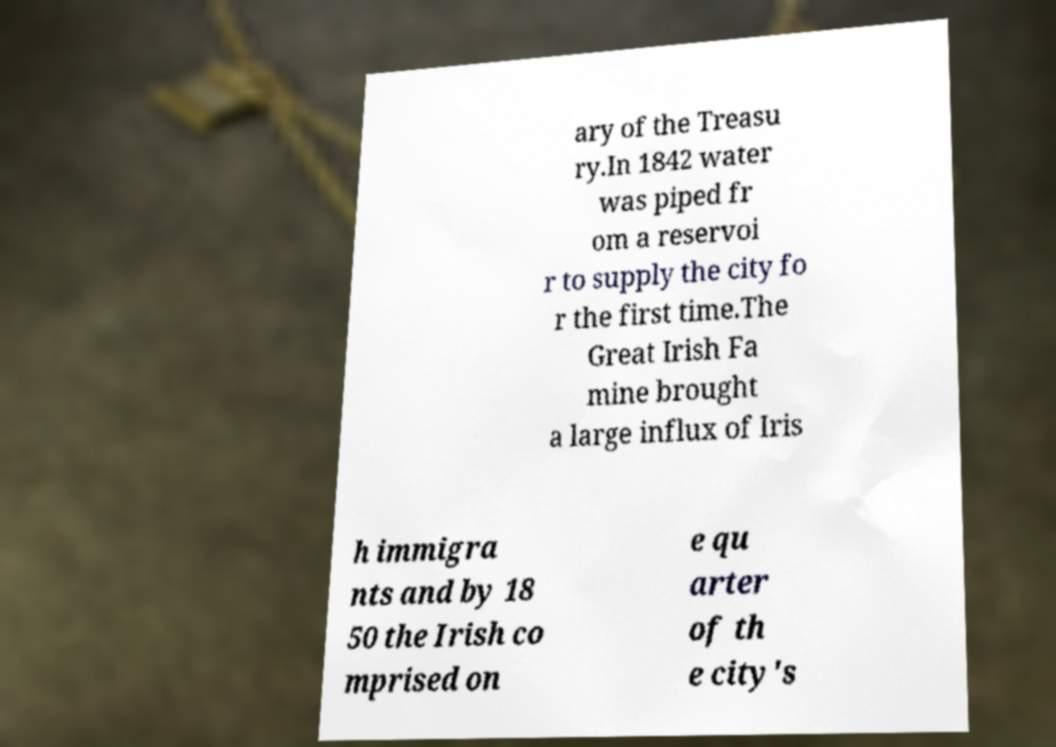I need the written content from this picture converted into text. Can you do that? ary of the Treasu ry.In 1842 water was piped fr om a reservoi r to supply the city fo r the first time.The Great Irish Fa mine brought a large influx of Iris h immigra nts and by 18 50 the Irish co mprised on e qu arter of th e city's 